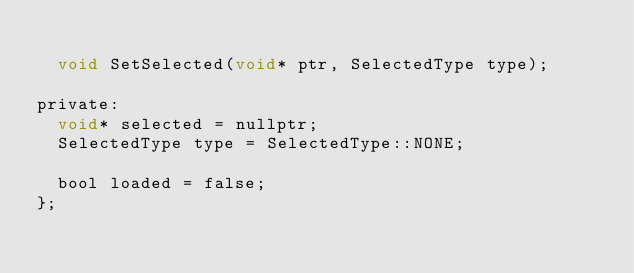<code> <loc_0><loc_0><loc_500><loc_500><_C_>
	void SetSelected(void* ptr, SelectedType type);

private:
	void* selected = nullptr;
	SelectedType type = SelectedType::NONE;

	bool loaded = false;
};

</code> 